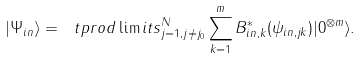Convert formula to latex. <formula><loc_0><loc_0><loc_500><loc_500>| \Psi _ { i n } \rangle = \ t p r o d \lim i t s _ { j = 1 , j \neq j _ { 0 } } ^ { N } \sum _ { k = 1 } ^ { m } B _ { i n , k } ^ { \ast } ( \psi _ { i n , j k } ) | 0 ^ { \otimes m } \rangle .</formula> 